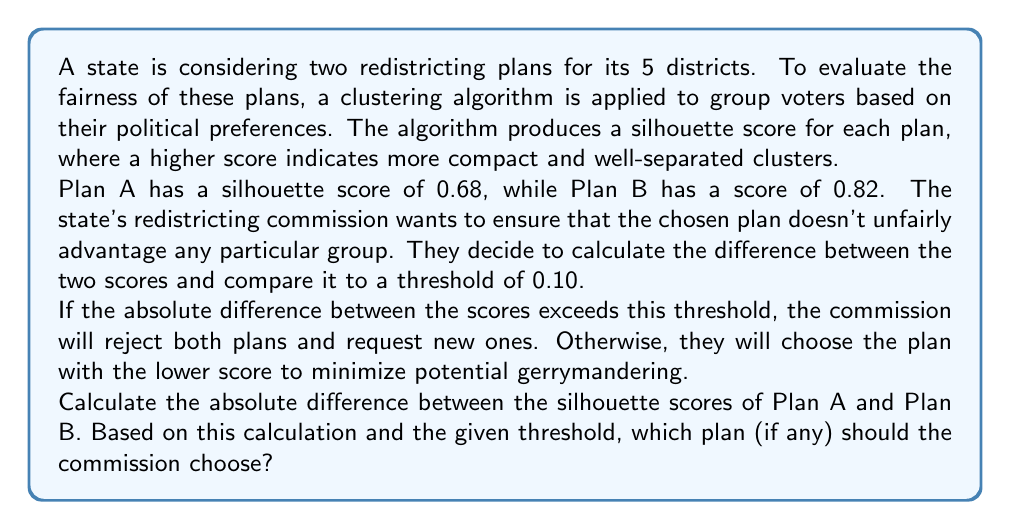What is the answer to this math problem? To solve this problem, we need to follow these steps:

1. Calculate the absolute difference between the silhouette scores of Plan A and Plan B.
2. Compare this difference to the given threshold.
3. Determine which plan to choose based on the comparison.

Step 1: Calculate the absolute difference
Let's define:
$s_A$ = silhouette score of Plan A = 0.68
$s_B$ = silhouette score of Plan B = 0.82

The absolute difference is given by:
$$|s_B - s_A| = |0.82 - 0.68| = 0.14$$

Step 2: Compare to the threshold
The threshold is given as 0.10.
Is 0.14 > 0.10? Yes, it is.

Step 3: Determine the chosen plan
Since the absolute difference (0.14) exceeds the threshold (0.10), according to the given rules, the commission should reject both plans and request new ones.

However, if we were to ignore the threshold and choose based on the lower score:
Plan A has a score of 0.68
Plan B has a score of 0.82
0.68 < 0.82, so Plan A would be chosen to minimize potential gerrymandering.

But in this case, we must adhere to the commission's rule about the threshold.
Answer: The absolute difference between the silhouette scores is 0.14. Since this exceeds the threshold of 0.10, the commission should reject both plans and request new ones. 